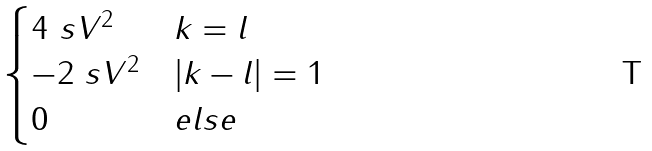Convert formula to latex. <formula><loc_0><loc_0><loc_500><loc_500>\begin{cases} 4 \ s V ^ { 2 } & k = l \\ - 2 \ s V ^ { 2 } & \left | k - l \right | = 1 \\ 0 & e l s e \end{cases}</formula> 